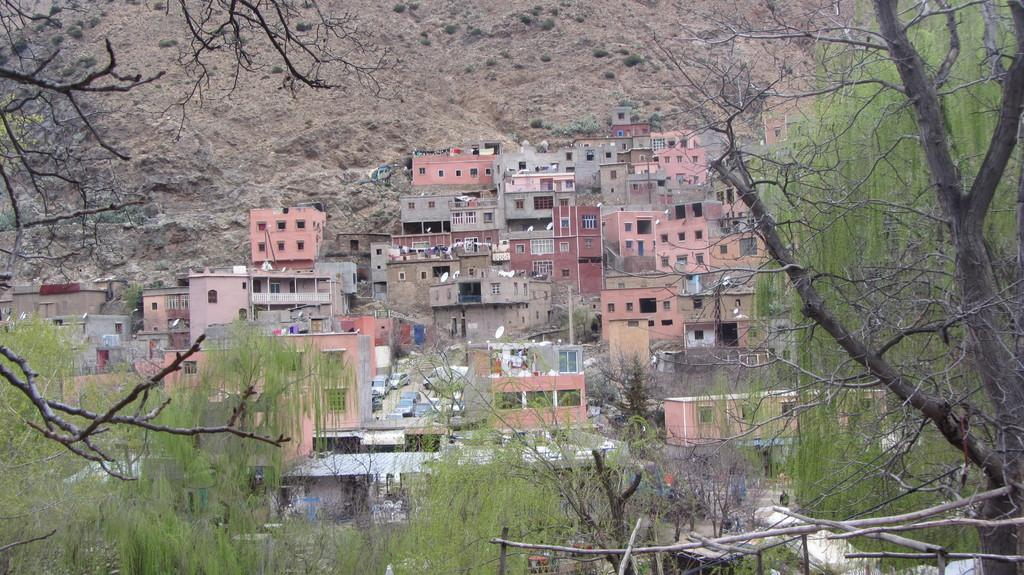What is located in the center of the image? There are buildings in the center of the image. What can be seen in the front of the image? There are trees in the front of the image. What is visible in the background of the image? There is a mountain in the background of the image. What type of tin can be seen on the bed in the image? There is no tin or bed present in the image; it features buildings, trees, and a mountain. What is the wax used for in the image? There is no wax present in the image. 